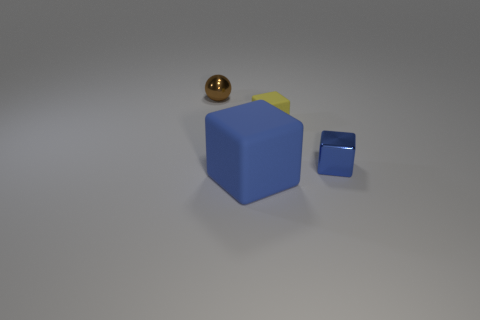Add 1 small metallic blocks. How many objects exist? 5 Subtract all balls. How many objects are left? 3 Add 2 brown metal balls. How many brown metal balls are left? 3 Add 3 yellow matte objects. How many yellow matte objects exist? 4 Subtract 1 yellow blocks. How many objects are left? 3 Subtract all gray objects. Subtract all tiny brown things. How many objects are left? 3 